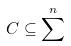<formula> <loc_0><loc_0><loc_500><loc_500>C \subseteq \sum ^ { n }</formula> 